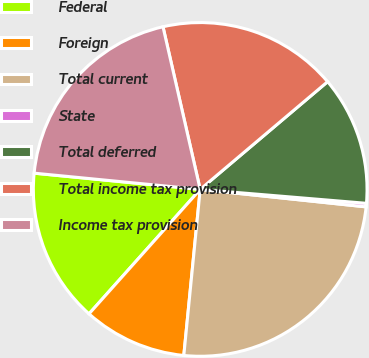Convert chart to OTSL. <chart><loc_0><loc_0><loc_500><loc_500><pie_chart><fcel>Federal<fcel>Foreign<fcel>Total current<fcel>State<fcel>Total deferred<fcel>Total income tax provision<fcel>Income tax provision<nl><fcel>14.95%<fcel>10.04%<fcel>24.9%<fcel>0.34%<fcel>12.5%<fcel>17.41%<fcel>19.87%<nl></chart> 